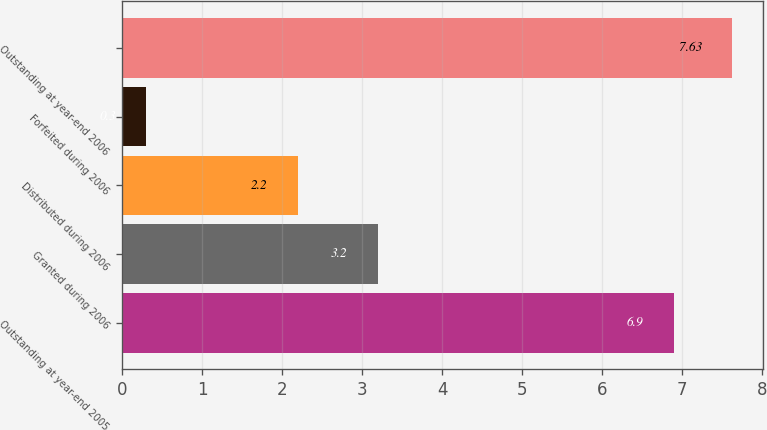Convert chart to OTSL. <chart><loc_0><loc_0><loc_500><loc_500><bar_chart><fcel>Outstanding at year-end 2005<fcel>Granted during 2006<fcel>Distributed during 2006<fcel>Forfeited during 2006<fcel>Outstanding at year-end 2006<nl><fcel>6.9<fcel>3.2<fcel>2.2<fcel>0.3<fcel>7.63<nl></chart> 